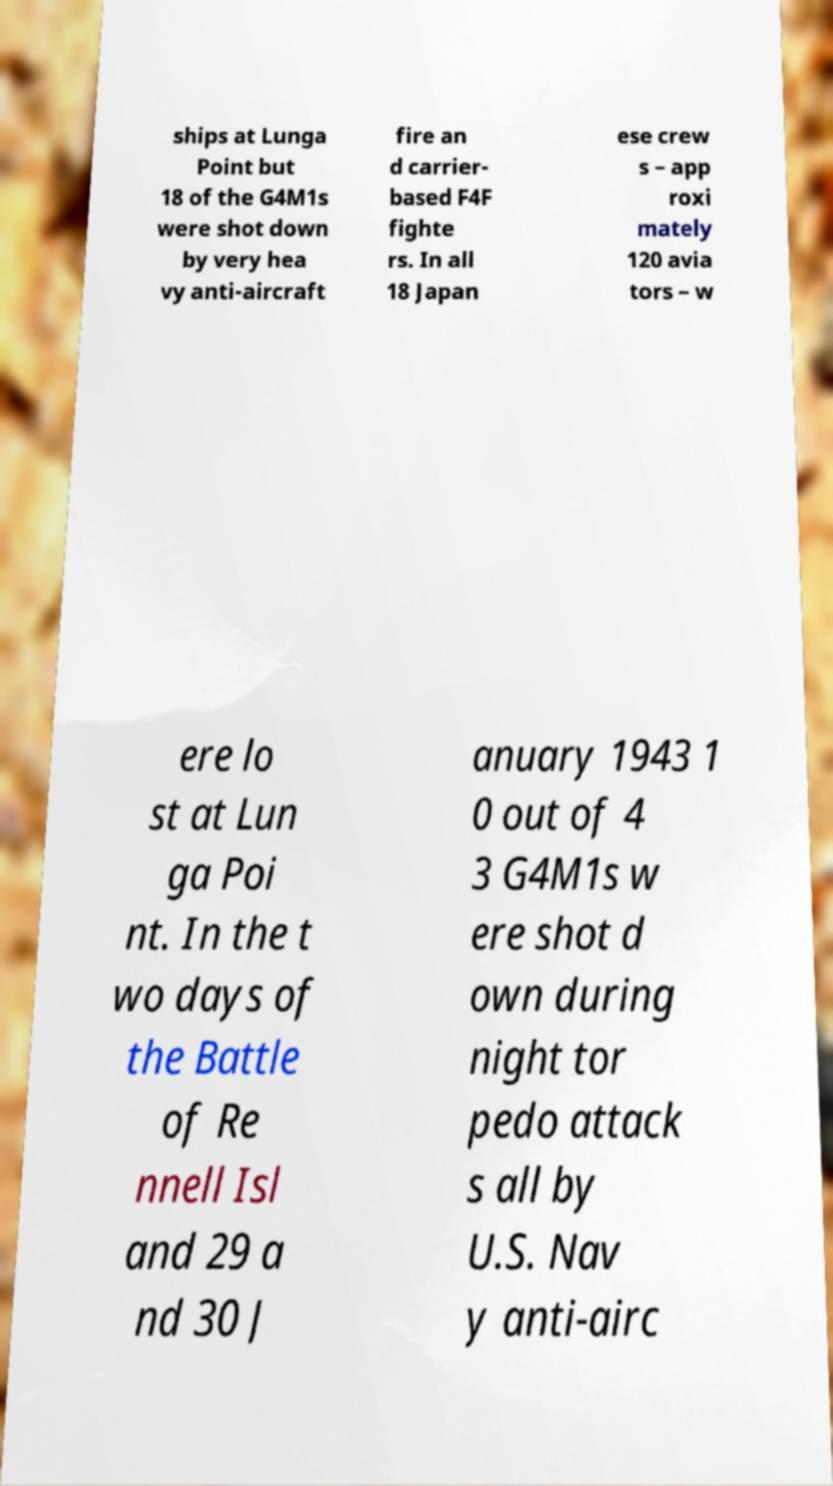There's text embedded in this image that I need extracted. Can you transcribe it verbatim? ships at Lunga Point but 18 of the G4M1s were shot down by very hea vy anti-aircraft fire an d carrier- based F4F fighte rs. In all 18 Japan ese crew s – app roxi mately 120 avia tors – w ere lo st at Lun ga Poi nt. In the t wo days of the Battle of Re nnell Isl and 29 a nd 30 J anuary 1943 1 0 out of 4 3 G4M1s w ere shot d own during night tor pedo attack s all by U.S. Nav y anti-airc 